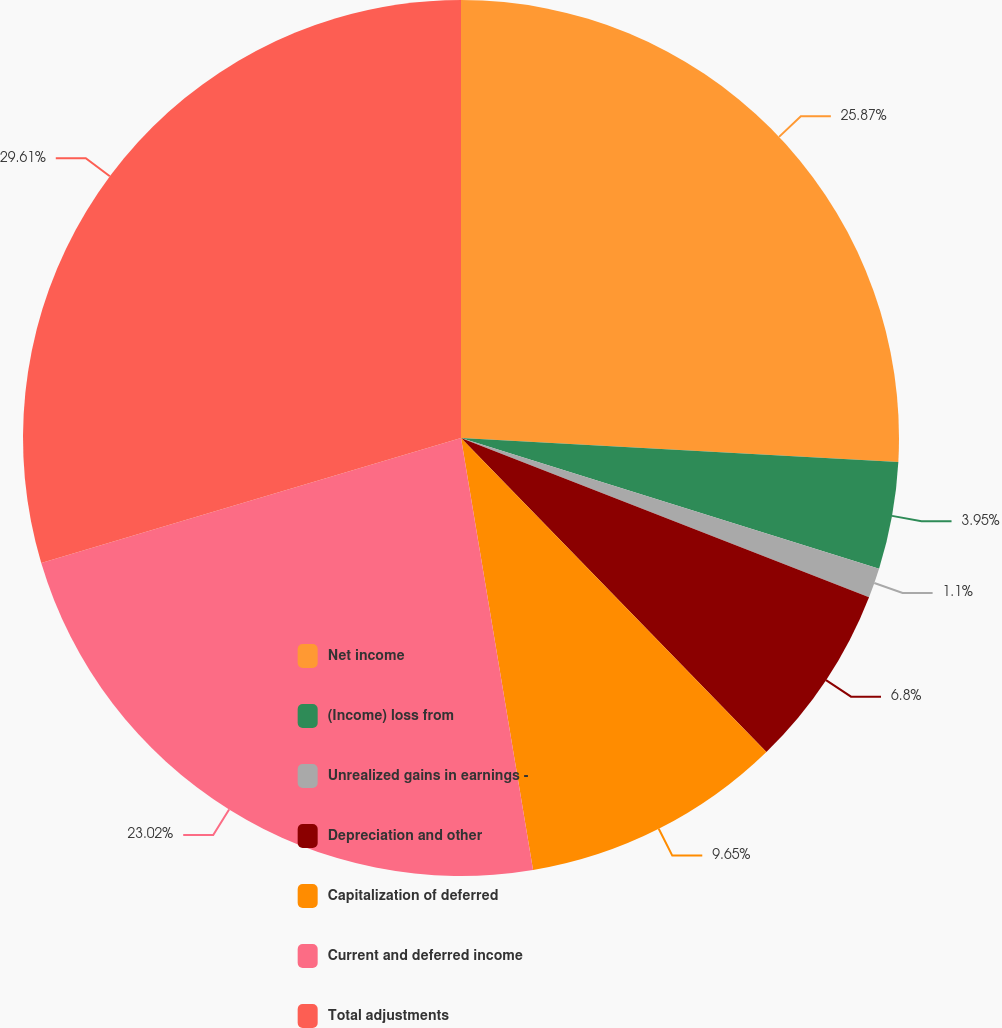Convert chart. <chart><loc_0><loc_0><loc_500><loc_500><pie_chart><fcel>Net income<fcel>(Income) loss from<fcel>Unrealized gains in earnings -<fcel>Depreciation and other<fcel>Capitalization of deferred<fcel>Current and deferred income<fcel>Total adjustments<nl><fcel>25.87%<fcel>3.95%<fcel>1.1%<fcel>6.8%<fcel>9.65%<fcel>23.02%<fcel>29.61%<nl></chart> 